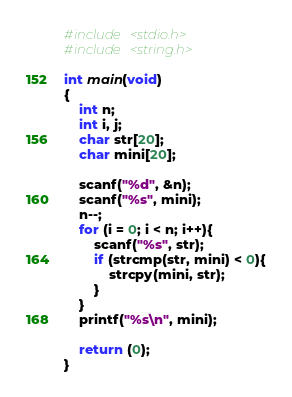Convert code to text. <code><loc_0><loc_0><loc_500><loc_500><_C_>#include <stdio.h>
#include <string.h>
 
int main(void)
{
    int n;
    int i, j;
    char str[20];
    char mini[20];
     
    scanf("%d", &n);
    scanf("%s", mini);
    n--;
    for (i = 0; i < n; i++){
        scanf("%s", str);
        if (strcmp(str, mini) < 0){
            strcpy(mini, str);
        }
    }
    printf("%s\n", mini);
     
    return (0);
}</code> 